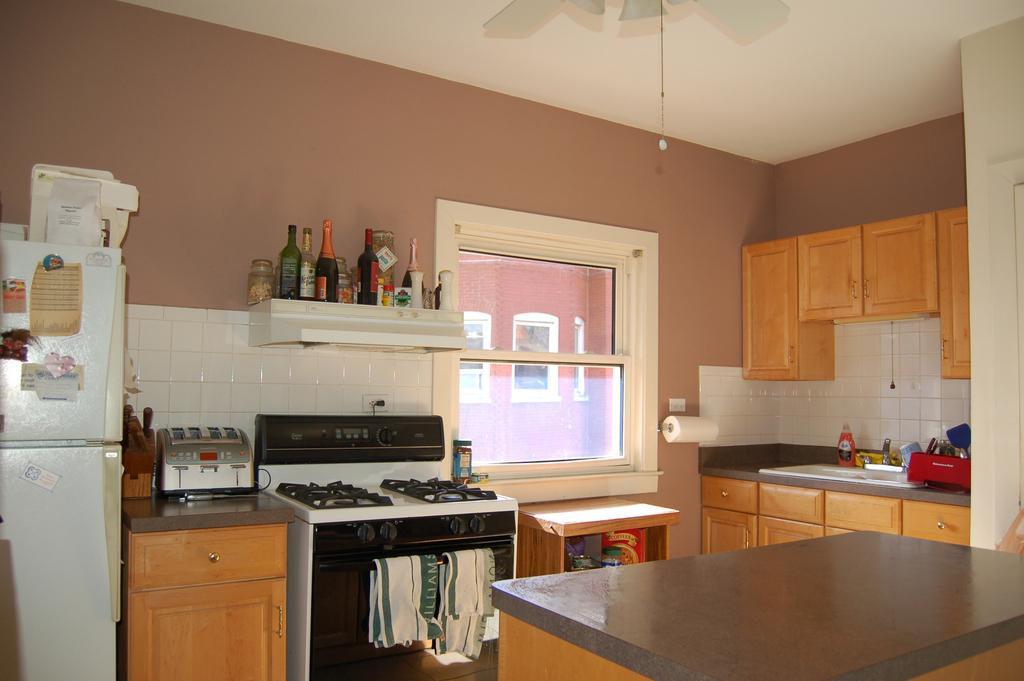Describe this image in one or two sentences. This is clicked inside a kitchen, there is a window in the middle of the wall with stove,table and refrigerator on the left side of it and racks,cupboards on the right side of it and beside the window there is shelf with wine bottles over it and above there is fan on the ceiling. 